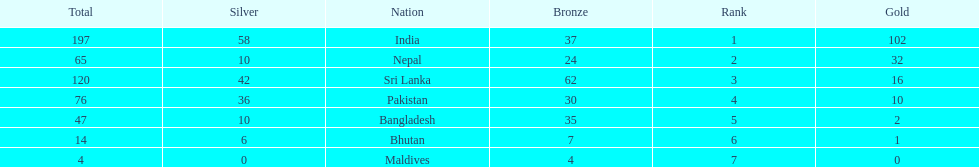Write the full table. {'header': ['Total', 'Silver', 'Nation', 'Bronze', 'Rank', 'Gold'], 'rows': [['197', '58', 'India', '37', '1', '102'], ['65', '10', 'Nepal', '24', '2', '32'], ['120', '42', 'Sri Lanka', '62', '3', '16'], ['76', '36', 'Pakistan', '30', '4', '10'], ['47', '10', 'Bangladesh', '35', '5', '2'], ['14', '6', 'Bhutan', '7', '6', '1'], ['4', '0', 'Maldives', '4', '7', '0']]} How many gold medals were awarded between all 7 nations? 163. 